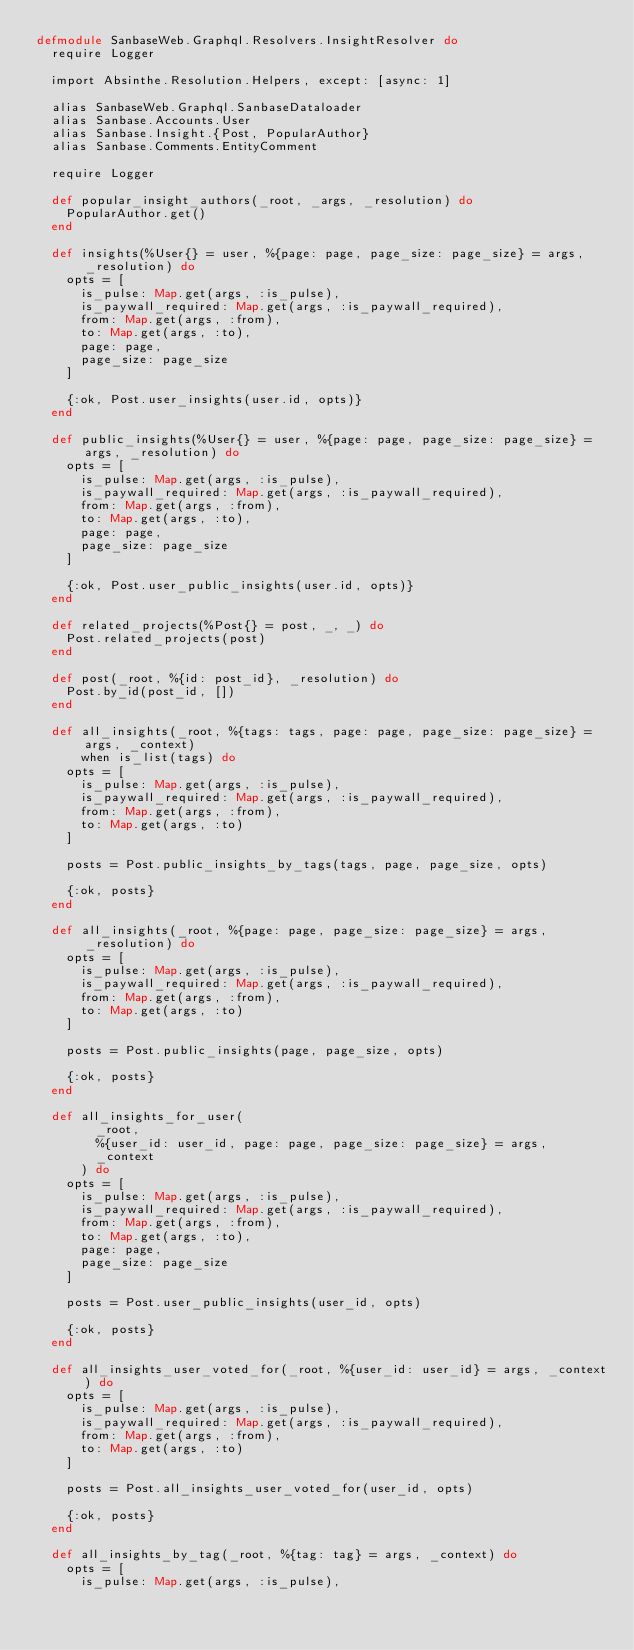Convert code to text. <code><loc_0><loc_0><loc_500><loc_500><_Elixir_>defmodule SanbaseWeb.Graphql.Resolvers.InsightResolver do
  require Logger

  import Absinthe.Resolution.Helpers, except: [async: 1]

  alias SanbaseWeb.Graphql.SanbaseDataloader
  alias Sanbase.Accounts.User
  alias Sanbase.Insight.{Post, PopularAuthor}
  alias Sanbase.Comments.EntityComment

  require Logger

  def popular_insight_authors(_root, _args, _resolution) do
    PopularAuthor.get()
  end

  def insights(%User{} = user, %{page: page, page_size: page_size} = args, _resolution) do
    opts = [
      is_pulse: Map.get(args, :is_pulse),
      is_paywall_required: Map.get(args, :is_paywall_required),
      from: Map.get(args, :from),
      to: Map.get(args, :to),
      page: page,
      page_size: page_size
    ]

    {:ok, Post.user_insights(user.id, opts)}
  end

  def public_insights(%User{} = user, %{page: page, page_size: page_size} = args, _resolution) do
    opts = [
      is_pulse: Map.get(args, :is_pulse),
      is_paywall_required: Map.get(args, :is_paywall_required),
      from: Map.get(args, :from),
      to: Map.get(args, :to),
      page: page,
      page_size: page_size
    ]

    {:ok, Post.user_public_insights(user.id, opts)}
  end

  def related_projects(%Post{} = post, _, _) do
    Post.related_projects(post)
  end

  def post(_root, %{id: post_id}, _resolution) do
    Post.by_id(post_id, [])
  end

  def all_insights(_root, %{tags: tags, page: page, page_size: page_size} = args, _context)
      when is_list(tags) do
    opts = [
      is_pulse: Map.get(args, :is_pulse),
      is_paywall_required: Map.get(args, :is_paywall_required),
      from: Map.get(args, :from),
      to: Map.get(args, :to)
    ]

    posts = Post.public_insights_by_tags(tags, page, page_size, opts)

    {:ok, posts}
  end

  def all_insights(_root, %{page: page, page_size: page_size} = args, _resolution) do
    opts = [
      is_pulse: Map.get(args, :is_pulse),
      is_paywall_required: Map.get(args, :is_paywall_required),
      from: Map.get(args, :from),
      to: Map.get(args, :to)
    ]

    posts = Post.public_insights(page, page_size, opts)

    {:ok, posts}
  end

  def all_insights_for_user(
        _root,
        %{user_id: user_id, page: page, page_size: page_size} = args,
        _context
      ) do
    opts = [
      is_pulse: Map.get(args, :is_pulse),
      is_paywall_required: Map.get(args, :is_paywall_required),
      from: Map.get(args, :from),
      to: Map.get(args, :to),
      page: page,
      page_size: page_size
    ]

    posts = Post.user_public_insights(user_id, opts)

    {:ok, posts}
  end

  def all_insights_user_voted_for(_root, %{user_id: user_id} = args, _context) do
    opts = [
      is_pulse: Map.get(args, :is_pulse),
      is_paywall_required: Map.get(args, :is_paywall_required),
      from: Map.get(args, :from),
      to: Map.get(args, :to)
    ]

    posts = Post.all_insights_user_voted_for(user_id, opts)

    {:ok, posts}
  end

  def all_insights_by_tag(_root, %{tag: tag} = args, _context) do
    opts = [
      is_pulse: Map.get(args, :is_pulse),</code> 